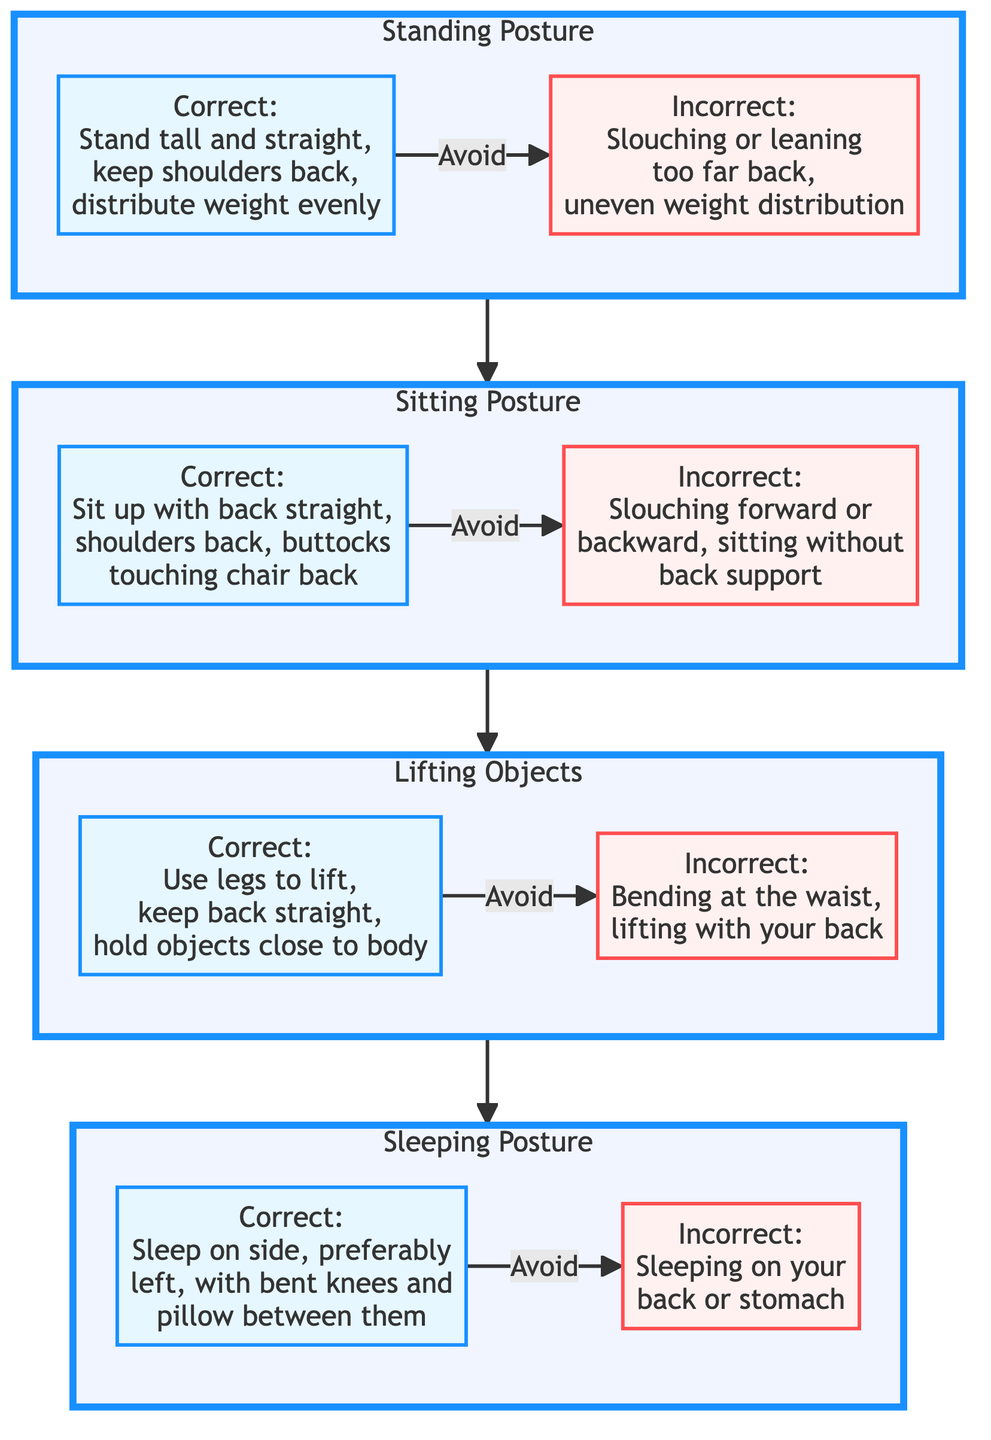What are the two types of posture shown in the Standing section? The Standing section has two types of posture labeled as Correct and Incorrect. The Correct posture involves standing tall and straight, keeping shoulders back, and distributing weight evenly. The Incorrect posture involves slouching or leaning too far back and uneven weight distribution.
Answer: Correct and Incorrect How many sections are there in the diagram? The diagram consists of four sections: Standing Posture, Sitting Posture, Lifting Objects, and Sleeping Posture. Each section addresses different postures for daily activities.
Answer: Four What is the recommended sleeping position for pregnant women? The diagram recommends sleeping on the side, preferably the left side, with bent knees and a pillow between them. This position is shown in the Sleeping section as the correct posture.
Answer: Sleep on side, preferably left What posture should be avoided while lifting objects? The diagram indicates that bending at the waist and lifting with the back should be avoided while lifting objects, as shown in the Lifting section.
Answer: Bending at the waist Which posture involves sitting without back support? The Incorrect posture in the Sitting section describes sitting without back support as a posture to avoid, contrasting with the Correct posture that emphasizes support from the chair back.
Answer: Sitting without back support What distinguishes the correct way to sit from the incorrect way? The Correct sitting posture requires sitting up with the back straight and shoulders back, while the Incorrect posture leads to slouching forward or backward. This distinction addresses the difference in the alignment and support of the back.
Answer: Back straight, shoulders back How are the sections of the diagram related? The sections are connected in a progression that illustrates proper postures for different activities, flowing from Standing to Sitting to Lifting and finally to Sleeping, showing a comprehensive approach to maintaining good posture throughout daily routines.
Answer: Flowing from Standing to Sitting to Lifting to Sleeping What should be done while lifting to maintain proper posture? According to the diagram, to lift properly, one should use the legs to lift, keep the back straight, and hold objects close to the body. These guidelines emphasize safe lifting practices that help prevent strain.
Answer: Use legs to lift, keep back straight What should a pregnant woman avoid when standing? The Incorrect posture in the Standing section indicates that a pregnant woman should avoid slouching or leaning too far back, as well as uneven weight distribution, which can lead to discomfort and poor posture.
Answer: Slouching or leaning too far back 